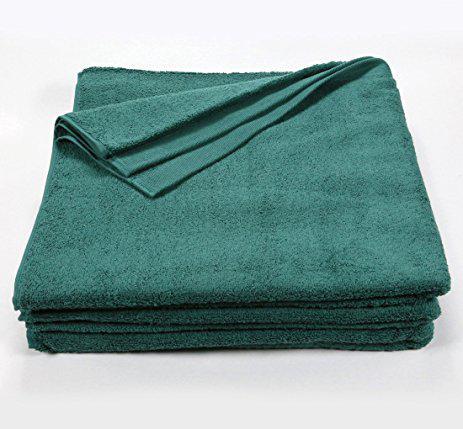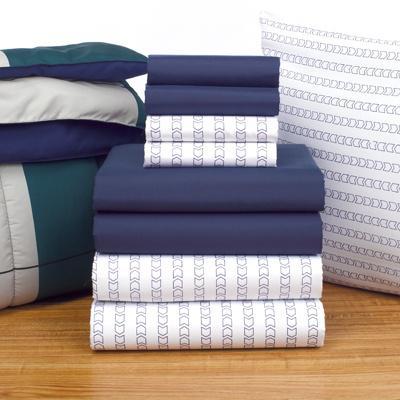The first image is the image on the left, the second image is the image on the right. Considering the images on both sides, is "In one image there are six green towels." valid? Answer yes or no. No. The first image is the image on the left, the second image is the image on the right. Given the left and right images, does the statement "There are exactly six towels in the right image." hold true? Answer yes or no. No. 